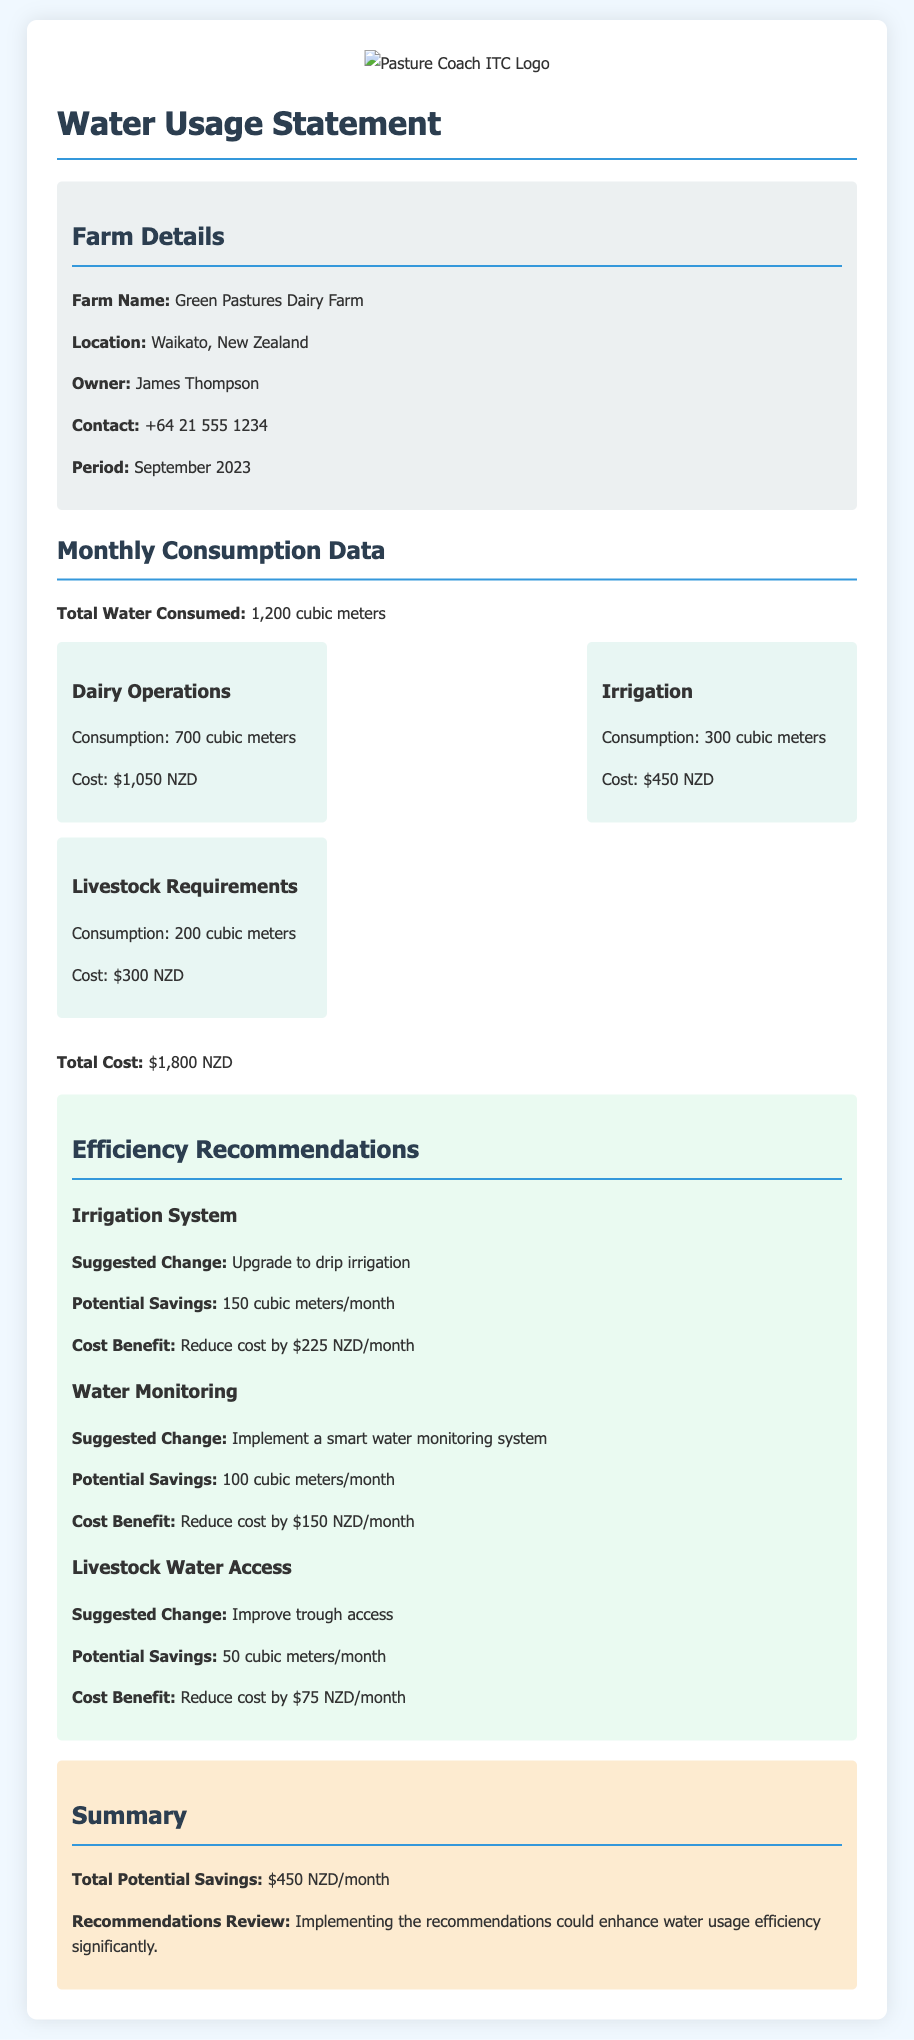what is the farm name? The farm name is stated in the "Farm Details" section of the document.
Answer: Green Pastures Dairy Farm who is the owner of the farm? The owner's name is provided in the "Farm Details" section of the document.
Answer: James Thompson what was the total water consumed in September 2023? The total water consumed is listed in the "Monthly Consumption Data" section of the document.
Answer: 1,200 cubic meters how much did dairy operations consume? The consumption for dairy operations can be found in the consumption data section.
Answer: 700 cubic meters what is the total cost for water usage? The total cost is summarized at the end of the monthly consumption data.
Answer: $1,800 NZD what potential savings can be achieved by upgrading to drip irrigation? The potential savings are mentioned under the recommendations for irrigation systems.
Answer: 150 cubic meters/month how much could costs be reduced by implementing a smart water monitoring system? The cost benefit for this recommendation is provided under water monitoring.
Answer: $150 NZD/month what is the total potential savings from all recommendations? The total potential savings is summarized in the "Summary" section of the document.
Answer: $450 NZD/month what type of document is this? The type of document is mentioned in the title at the top of the document.
Answer: Water Usage Statement 